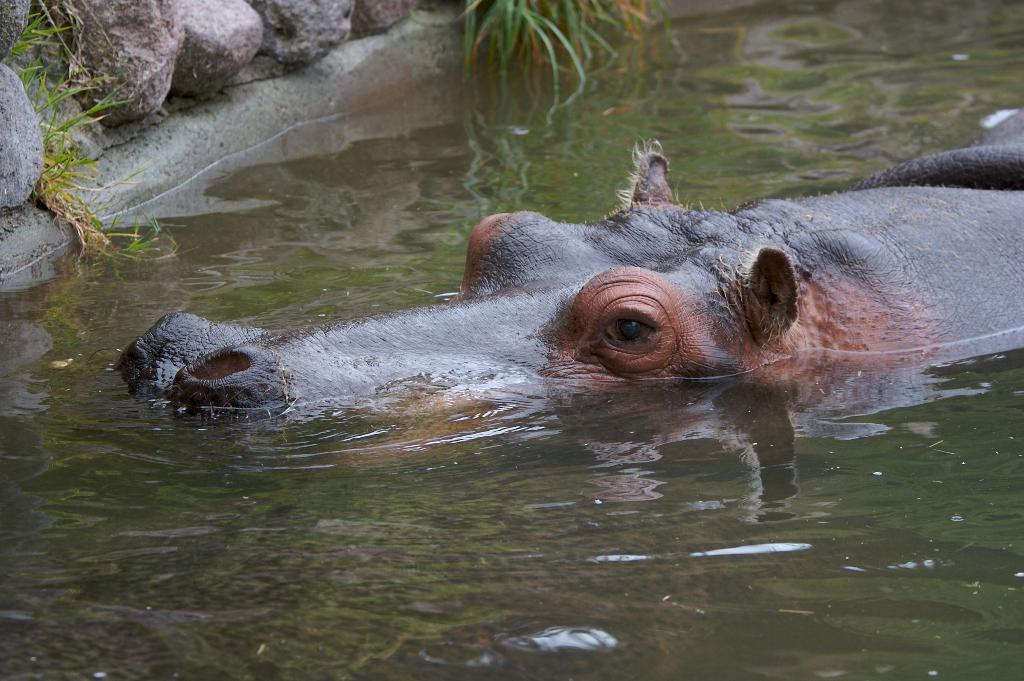What animal can be seen in the water in the image? There is a hippopotamus in the water in the image. What type of objects can be seen in the background of the image? There are stones in the background of the image. What type of vegetation can be seen in the water in the background of the image? There is grass in the water in the background of the image. How many light bulbs can be seen in the image? There are no light bulbs present in the image. 